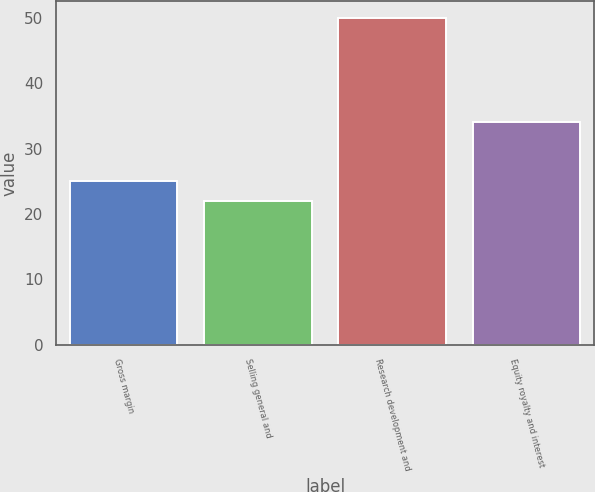Convert chart. <chart><loc_0><loc_0><loc_500><loc_500><bar_chart><fcel>Gross margin<fcel>Selling general and<fcel>Research development and<fcel>Equity royalty and interest<nl><fcel>25<fcel>22<fcel>50<fcel>34<nl></chart> 